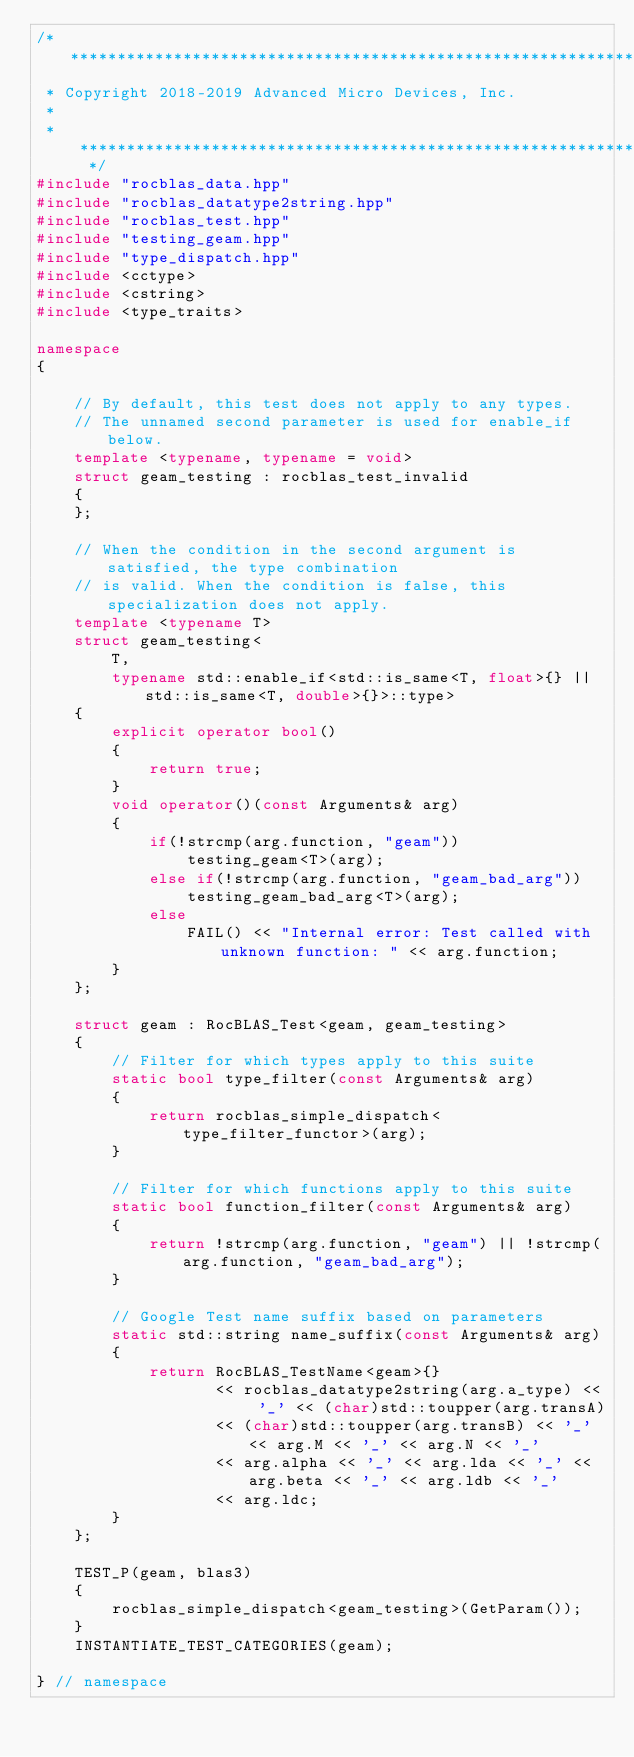Convert code to text. <code><loc_0><loc_0><loc_500><loc_500><_C++_>/* ************************************************************************
 * Copyright 2018-2019 Advanced Micro Devices, Inc.
 *
 * ************************************************************************ */
#include "rocblas_data.hpp"
#include "rocblas_datatype2string.hpp"
#include "rocblas_test.hpp"
#include "testing_geam.hpp"
#include "type_dispatch.hpp"
#include <cctype>
#include <cstring>
#include <type_traits>

namespace
{

    // By default, this test does not apply to any types.
    // The unnamed second parameter is used for enable_if below.
    template <typename, typename = void>
    struct geam_testing : rocblas_test_invalid
    {
    };

    // When the condition in the second argument is satisfied, the type combination
    // is valid. When the condition is false, this specialization does not apply.
    template <typename T>
    struct geam_testing<
        T,
        typename std::enable_if<std::is_same<T, float>{} || std::is_same<T, double>{}>::type>
    {
        explicit operator bool()
        {
            return true;
        }
        void operator()(const Arguments& arg)
        {
            if(!strcmp(arg.function, "geam"))
                testing_geam<T>(arg);
            else if(!strcmp(arg.function, "geam_bad_arg"))
                testing_geam_bad_arg<T>(arg);
            else
                FAIL() << "Internal error: Test called with unknown function: " << arg.function;
        }
    };

    struct geam : RocBLAS_Test<geam, geam_testing>
    {
        // Filter for which types apply to this suite
        static bool type_filter(const Arguments& arg)
        {
            return rocblas_simple_dispatch<type_filter_functor>(arg);
        }

        // Filter for which functions apply to this suite
        static bool function_filter(const Arguments& arg)
        {
            return !strcmp(arg.function, "geam") || !strcmp(arg.function, "geam_bad_arg");
        }

        // Google Test name suffix based on parameters
        static std::string name_suffix(const Arguments& arg)
        {
            return RocBLAS_TestName<geam>{}
                   << rocblas_datatype2string(arg.a_type) << '_' << (char)std::toupper(arg.transA)
                   << (char)std::toupper(arg.transB) << '_' << arg.M << '_' << arg.N << '_'
                   << arg.alpha << '_' << arg.lda << '_' << arg.beta << '_' << arg.ldb << '_'
                   << arg.ldc;
        }
    };

    TEST_P(geam, blas3)
    {
        rocblas_simple_dispatch<geam_testing>(GetParam());
    }
    INSTANTIATE_TEST_CATEGORIES(geam);

} // namespace
</code> 